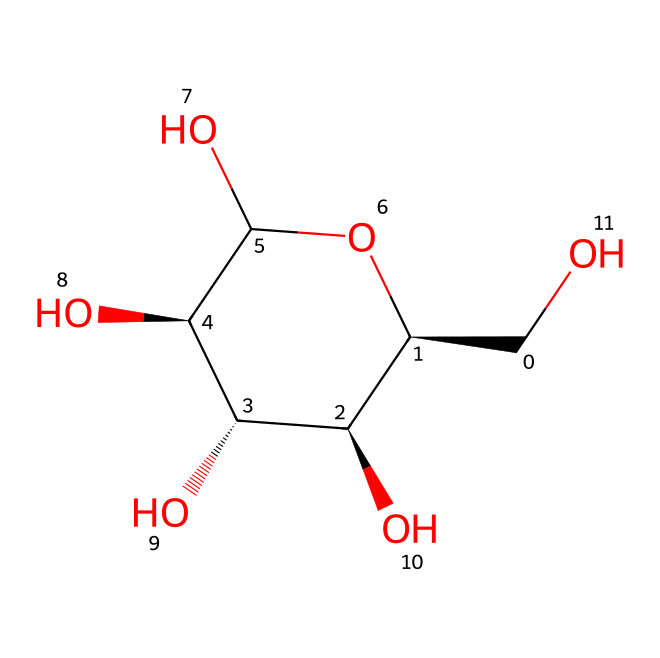How many carbon atoms are in this structure? The molecular structure depicted shows six carbon (C) atoms connected in a way that forms a ring, indicating that it is a sugar. By counting the carbon atoms in the provided SMILES representation, we find there are six carbon atoms total.
Answer: six What functional groups are present in this molecule? In the structure, hydroxyl (–OH) groups are abundant; each carbon except one has a hydroxyl group attached. This indicates that the chemical is a carbohydrate with multiple alcohol functional groups.
Answer: hydroxyl groups What type of carbohydrate is represented by this structure? This SMILES notation represents a polysaccharide since it has multiple repeating units of sugar (monosaccharides) combined. More specifically, the structure indicates that it is cellulose, a major component found in plant cell walls.
Answer: polysaccharide What is the degree of saturation of this carbohydrate? The structure does not contain any double or triple bonds, indicating that all carbon atoms are fully saturated with hydrogen and hydroxyl groups. Therefore, the degree of saturation can be considered as fully saturated.
Answer: fully saturated How many oxygen atoms are in this structure? In the molecular structure, there are five oxygen (O) atoms present, counting each one found in the hydroxyl groups attached to the carbon atoms.
Answer: five 